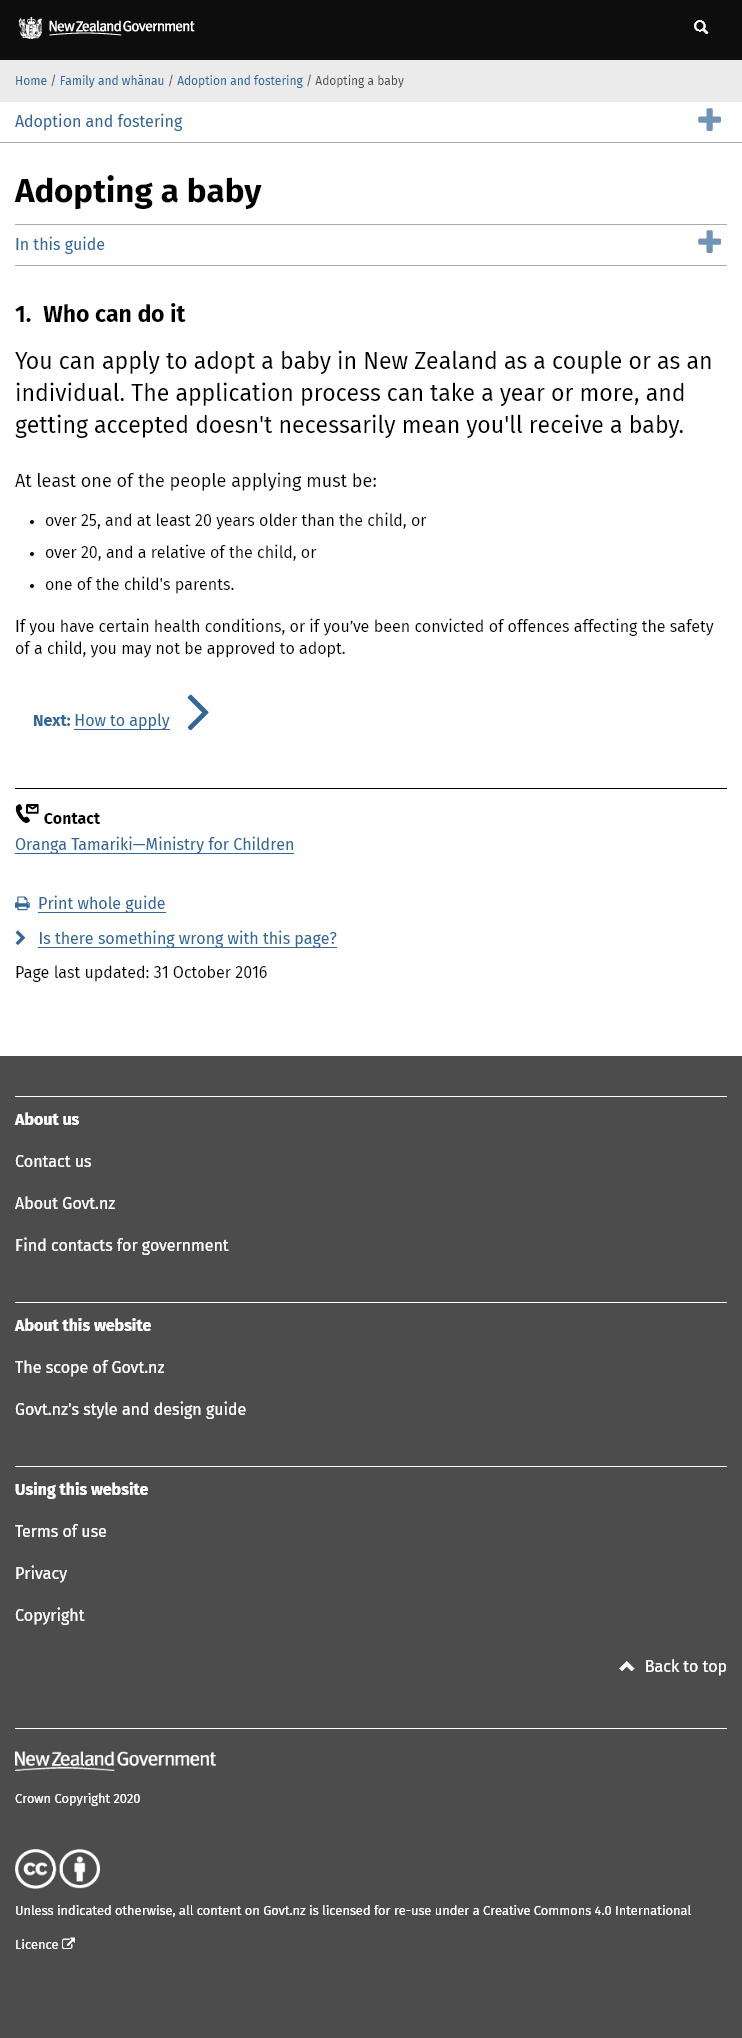Specify some key components in this picture. To apply to adopt a baby, one of the individuals applying must be at least 20 years older than the child or over 25, and meet either of the following requirements: (1) be a relative of the child or (2) be one of the child's parents. Yes, it is possible for an individual to adopt a baby in New Zealand. One can apply to adopt a baby in this country. This guide is about the process of adopting a baby. 